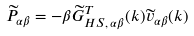Convert formula to latex. <formula><loc_0><loc_0><loc_500><loc_500>\widetilde { P } _ { \alpha \beta } = - \beta \widetilde { G } _ { H S , \, \alpha \beta } ^ { T } ( k ) \widetilde { v } _ { \alpha \beta } ( k ) \,</formula> 